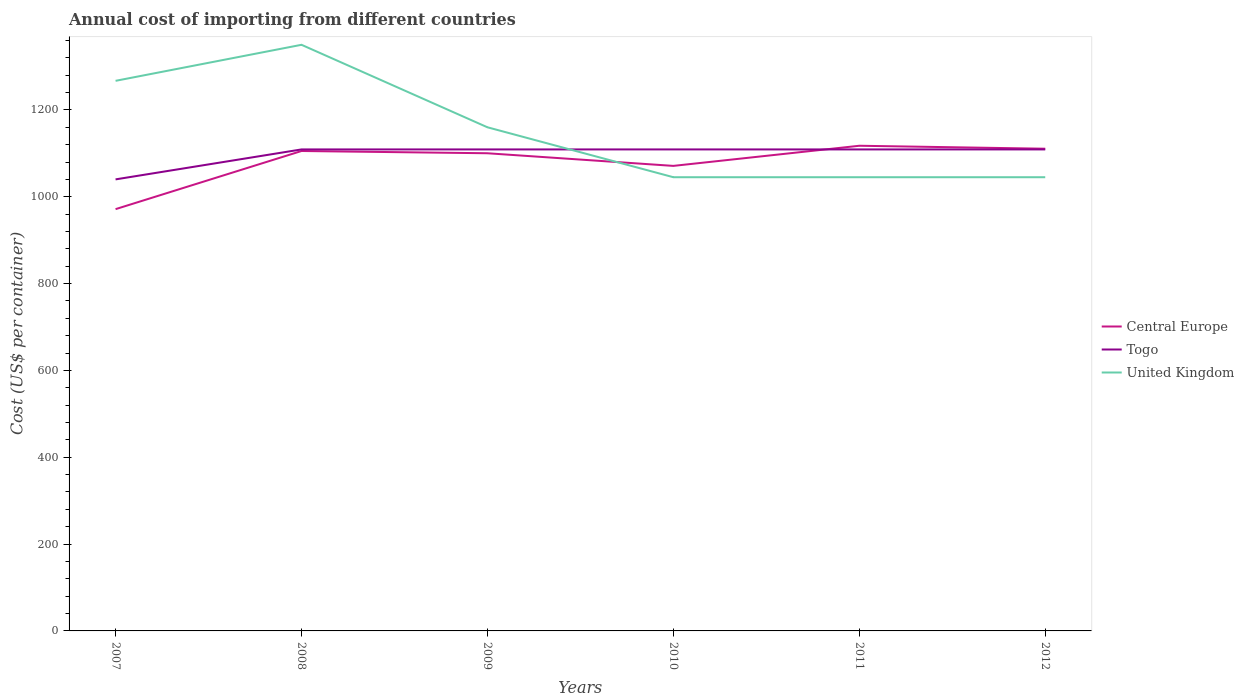How many different coloured lines are there?
Give a very brief answer. 3. Does the line corresponding to United Kingdom intersect with the line corresponding to Central Europe?
Provide a short and direct response. Yes. Across all years, what is the maximum total annual cost of importing in Central Europe?
Give a very brief answer. 971.45. What is the total total annual cost of importing in United Kingdom in the graph?
Your answer should be very brief. 107. What is the difference between the highest and the second highest total annual cost of importing in United Kingdom?
Provide a succinct answer. 305. Is the total annual cost of importing in United Kingdom strictly greater than the total annual cost of importing in Togo over the years?
Give a very brief answer. No. How many lines are there?
Your answer should be very brief. 3. How many legend labels are there?
Keep it short and to the point. 3. What is the title of the graph?
Offer a terse response. Annual cost of importing from different countries. What is the label or title of the Y-axis?
Your answer should be very brief. Cost (US$ per container). What is the Cost (US$ per container) of Central Europe in 2007?
Make the answer very short. 971.45. What is the Cost (US$ per container) in Togo in 2007?
Ensure brevity in your answer.  1040. What is the Cost (US$ per container) of United Kingdom in 2007?
Your answer should be very brief. 1267. What is the Cost (US$ per container) of Central Europe in 2008?
Ensure brevity in your answer.  1105.36. What is the Cost (US$ per container) of Togo in 2008?
Offer a very short reply. 1109. What is the Cost (US$ per container) of United Kingdom in 2008?
Offer a very short reply. 1350. What is the Cost (US$ per container) in Central Europe in 2009?
Your response must be concise. 1100.18. What is the Cost (US$ per container) in Togo in 2009?
Offer a terse response. 1109. What is the Cost (US$ per container) of United Kingdom in 2009?
Provide a succinct answer. 1160. What is the Cost (US$ per container) of Central Europe in 2010?
Your answer should be compact. 1071.09. What is the Cost (US$ per container) of Togo in 2010?
Your answer should be very brief. 1109. What is the Cost (US$ per container) in United Kingdom in 2010?
Give a very brief answer. 1045. What is the Cost (US$ per container) in Central Europe in 2011?
Your answer should be very brief. 1117.45. What is the Cost (US$ per container) in Togo in 2011?
Offer a very short reply. 1109. What is the Cost (US$ per container) of United Kingdom in 2011?
Your response must be concise. 1045. What is the Cost (US$ per container) of Central Europe in 2012?
Offer a terse response. 1110.64. What is the Cost (US$ per container) in Togo in 2012?
Keep it short and to the point. 1109. What is the Cost (US$ per container) in United Kingdom in 2012?
Provide a short and direct response. 1045. Across all years, what is the maximum Cost (US$ per container) of Central Europe?
Keep it short and to the point. 1117.45. Across all years, what is the maximum Cost (US$ per container) of Togo?
Offer a terse response. 1109. Across all years, what is the maximum Cost (US$ per container) in United Kingdom?
Give a very brief answer. 1350. Across all years, what is the minimum Cost (US$ per container) in Central Europe?
Offer a very short reply. 971.45. Across all years, what is the minimum Cost (US$ per container) in Togo?
Offer a very short reply. 1040. Across all years, what is the minimum Cost (US$ per container) in United Kingdom?
Offer a very short reply. 1045. What is the total Cost (US$ per container) of Central Europe in the graph?
Provide a short and direct response. 6476.18. What is the total Cost (US$ per container) of Togo in the graph?
Give a very brief answer. 6585. What is the total Cost (US$ per container) of United Kingdom in the graph?
Your answer should be very brief. 6912. What is the difference between the Cost (US$ per container) of Central Europe in 2007 and that in 2008?
Your response must be concise. -133.91. What is the difference between the Cost (US$ per container) of Togo in 2007 and that in 2008?
Keep it short and to the point. -69. What is the difference between the Cost (US$ per container) of United Kingdom in 2007 and that in 2008?
Provide a short and direct response. -83. What is the difference between the Cost (US$ per container) of Central Europe in 2007 and that in 2009?
Provide a short and direct response. -128.73. What is the difference between the Cost (US$ per container) of Togo in 2007 and that in 2009?
Your answer should be compact. -69. What is the difference between the Cost (US$ per container) in United Kingdom in 2007 and that in 2009?
Provide a succinct answer. 107. What is the difference between the Cost (US$ per container) of Central Europe in 2007 and that in 2010?
Give a very brief answer. -99.64. What is the difference between the Cost (US$ per container) in Togo in 2007 and that in 2010?
Ensure brevity in your answer.  -69. What is the difference between the Cost (US$ per container) in United Kingdom in 2007 and that in 2010?
Your answer should be very brief. 222. What is the difference between the Cost (US$ per container) in Central Europe in 2007 and that in 2011?
Ensure brevity in your answer.  -146. What is the difference between the Cost (US$ per container) in Togo in 2007 and that in 2011?
Make the answer very short. -69. What is the difference between the Cost (US$ per container) in United Kingdom in 2007 and that in 2011?
Ensure brevity in your answer.  222. What is the difference between the Cost (US$ per container) in Central Europe in 2007 and that in 2012?
Make the answer very short. -139.18. What is the difference between the Cost (US$ per container) in Togo in 2007 and that in 2012?
Offer a terse response. -69. What is the difference between the Cost (US$ per container) in United Kingdom in 2007 and that in 2012?
Your response must be concise. 222. What is the difference between the Cost (US$ per container) in Central Europe in 2008 and that in 2009?
Your answer should be very brief. 5.18. What is the difference between the Cost (US$ per container) in United Kingdom in 2008 and that in 2009?
Your response must be concise. 190. What is the difference between the Cost (US$ per container) of Central Europe in 2008 and that in 2010?
Offer a terse response. 34.27. What is the difference between the Cost (US$ per container) in Togo in 2008 and that in 2010?
Make the answer very short. 0. What is the difference between the Cost (US$ per container) in United Kingdom in 2008 and that in 2010?
Provide a short and direct response. 305. What is the difference between the Cost (US$ per container) in Central Europe in 2008 and that in 2011?
Ensure brevity in your answer.  -12.09. What is the difference between the Cost (US$ per container) of Togo in 2008 and that in 2011?
Your answer should be compact. 0. What is the difference between the Cost (US$ per container) in United Kingdom in 2008 and that in 2011?
Your response must be concise. 305. What is the difference between the Cost (US$ per container) in Central Europe in 2008 and that in 2012?
Ensure brevity in your answer.  -5.27. What is the difference between the Cost (US$ per container) in Togo in 2008 and that in 2012?
Offer a terse response. 0. What is the difference between the Cost (US$ per container) of United Kingdom in 2008 and that in 2012?
Give a very brief answer. 305. What is the difference between the Cost (US$ per container) in Central Europe in 2009 and that in 2010?
Give a very brief answer. 29.09. What is the difference between the Cost (US$ per container) of Togo in 2009 and that in 2010?
Provide a short and direct response. 0. What is the difference between the Cost (US$ per container) of United Kingdom in 2009 and that in 2010?
Your answer should be very brief. 115. What is the difference between the Cost (US$ per container) of Central Europe in 2009 and that in 2011?
Your answer should be very brief. -17.27. What is the difference between the Cost (US$ per container) of Togo in 2009 and that in 2011?
Provide a short and direct response. 0. What is the difference between the Cost (US$ per container) of United Kingdom in 2009 and that in 2011?
Your answer should be compact. 115. What is the difference between the Cost (US$ per container) in Central Europe in 2009 and that in 2012?
Provide a succinct answer. -10.45. What is the difference between the Cost (US$ per container) of United Kingdom in 2009 and that in 2012?
Your answer should be compact. 115. What is the difference between the Cost (US$ per container) of Central Europe in 2010 and that in 2011?
Offer a very short reply. -46.36. What is the difference between the Cost (US$ per container) of United Kingdom in 2010 and that in 2011?
Ensure brevity in your answer.  0. What is the difference between the Cost (US$ per container) of Central Europe in 2010 and that in 2012?
Your answer should be compact. -39.55. What is the difference between the Cost (US$ per container) of Togo in 2010 and that in 2012?
Offer a very short reply. 0. What is the difference between the Cost (US$ per container) of Central Europe in 2011 and that in 2012?
Ensure brevity in your answer.  6.82. What is the difference between the Cost (US$ per container) in United Kingdom in 2011 and that in 2012?
Your answer should be very brief. 0. What is the difference between the Cost (US$ per container) in Central Europe in 2007 and the Cost (US$ per container) in Togo in 2008?
Keep it short and to the point. -137.55. What is the difference between the Cost (US$ per container) of Central Europe in 2007 and the Cost (US$ per container) of United Kingdom in 2008?
Offer a very short reply. -378.55. What is the difference between the Cost (US$ per container) in Togo in 2007 and the Cost (US$ per container) in United Kingdom in 2008?
Keep it short and to the point. -310. What is the difference between the Cost (US$ per container) in Central Europe in 2007 and the Cost (US$ per container) in Togo in 2009?
Provide a short and direct response. -137.55. What is the difference between the Cost (US$ per container) of Central Europe in 2007 and the Cost (US$ per container) of United Kingdom in 2009?
Your response must be concise. -188.55. What is the difference between the Cost (US$ per container) of Togo in 2007 and the Cost (US$ per container) of United Kingdom in 2009?
Offer a terse response. -120. What is the difference between the Cost (US$ per container) in Central Europe in 2007 and the Cost (US$ per container) in Togo in 2010?
Provide a succinct answer. -137.55. What is the difference between the Cost (US$ per container) of Central Europe in 2007 and the Cost (US$ per container) of United Kingdom in 2010?
Make the answer very short. -73.55. What is the difference between the Cost (US$ per container) in Central Europe in 2007 and the Cost (US$ per container) in Togo in 2011?
Make the answer very short. -137.55. What is the difference between the Cost (US$ per container) in Central Europe in 2007 and the Cost (US$ per container) in United Kingdom in 2011?
Keep it short and to the point. -73.55. What is the difference between the Cost (US$ per container) in Central Europe in 2007 and the Cost (US$ per container) in Togo in 2012?
Offer a terse response. -137.55. What is the difference between the Cost (US$ per container) of Central Europe in 2007 and the Cost (US$ per container) of United Kingdom in 2012?
Provide a short and direct response. -73.55. What is the difference between the Cost (US$ per container) of Togo in 2007 and the Cost (US$ per container) of United Kingdom in 2012?
Offer a terse response. -5. What is the difference between the Cost (US$ per container) in Central Europe in 2008 and the Cost (US$ per container) in Togo in 2009?
Your answer should be compact. -3.64. What is the difference between the Cost (US$ per container) in Central Europe in 2008 and the Cost (US$ per container) in United Kingdom in 2009?
Provide a succinct answer. -54.64. What is the difference between the Cost (US$ per container) of Togo in 2008 and the Cost (US$ per container) of United Kingdom in 2009?
Offer a terse response. -51. What is the difference between the Cost (US$ per container) in Central Europe in 2008 and the Cost (US$ per container) in Togo in 2010?
Offer a terse response. -3.64. What is the difference between the Cost (US$ per container) in Central Europe in 2008 and the Cost (US$ per container) in United Kingdom in 2010?
Ensure brevity in your answer.  60.36. What is the difference between the Cost (US$ per container) in Togo in 2008 and the Cost (US$ per container) in United Kingdom in 2010?
Your answer should be compact. 64. What is the difference between the Cost (US$ per container) in Central Europe in 2008 and the Cost (US$ per container) in Togo in 2011?
Keep it short and to the point. -3.64. What is the difference between the Cost (US$ per container) in Central Europe in 2008 and the Cost (US$ per container) in United Kingdom in 2011?
Your answer should be very brief. 60.36. What is the difference between the Cost (US$ per container) of Central Europe in 2008 and the Cost (US$ per container) of Togo in 2012?
Your response must be concise. -3.64. What is the difference between the Cost (US$ per container) in Central Europe in 2008 and the Cost (US$ per container) in United Kingdom in 2012?
Make the answer very short. 60.36. What is the difference between the Cost (US$ per container) of Togo in 2008 and the Cost (US$ per container) of United Kingdom in 2012?
Your answer should be compact. 64. What is the difference between the Cost (US$ per container) of Central Europe in 2009 and the Cost (US$ per container) of Togo in 2010?
Your response must be concise. -8.82. What is the difference between the Cost (US$ per container) in Central Europe in 2009 and the Cost (US$ per container) in United Kingdom in 2010?
Offer a very short reply. 55.18. What is the difference between the Cost (US$ per container) of Central Europe in 2009 and the Cost (US$ per container) of Togo in 2011?
Make the answer very short. -8.82. What is the difference between the Cost (US$ per container) in Central Europe in 2009 and the Cost (US$ per container) in United Kingdom in 2011?
Offer a terse response. 55.18. What is the difference between the Cost (US$ per container) in Togo in 2009 and the Cost (US$ per container) in United Kingdom in 2011?
Your answer should be very brief. 64. What is the difference between the Cost (US$ per container) of Central Europe in 2009 and the Cost (US$ per container) of Togo in 2012?
Your answer should be very brief. -8.82. What is the difference between the Cost (US$ per container) of Central Europe in 2009 and the Cost (US$ per container) of United Kingdom in 2012?
Keep it short and to the point. 55.18. What is the difference between the Cost (US$ per container) in Central Europe in 2010 and the Cost (US$ per container) in Togo in 2011?
Keep it short and to the point. -37.91. What is the difference between the Cost (US$ per container) of Central Europe in 2010 and the Cost (US$ per container) of United Kingdom in 2011?
Offer a very short reply. 26.09. What is the difference between the Cost (US$ per container) in Togo in 2010 and the Cost (US$ per container) in United Kingdom in 2011?
Make the answer very short. 64. What is the difference between the Cost (US$ per container) of Central Europe in 2010 and the Cost (US$ per container) of Togo in 2012?
Provide a succinct answer. -37.91. What is the difference between the Cost (US$ per container) of Central Europe in 2010 and the Cost (US$ per container) of United Kingdom in 2012?
Ensure brevity in your answer.  26.09. What is the difference between the Cost (US$ per container) of Togo in 2010 and the Cost (US$ per container) of United Kingdom in 2012?
Give a very brief answer. 64. What is the difference between the Cost (US$ per container) in Central Europe in 2011 and the Cost (US$ per container) in Togo in 2012?
Offer a terse response. 8.45. What is the difference between the Cost (US$ per container) of Central Europe in 2011 and the Cost (US$ per container) of United Kingdom in 2012?
Provide a succinct answer. 72.45. What is the average Cost (US$ per container) in Central Europe per year?
Your response must be concise. 1079.36. What is the average Cost (US$ per container) in Togo per year?
Offer a terse response. 1097.5. What is the average Cost (US$ per container) in United Kingdom per year?
Your response must be concise. 1152. In the year 2007, what is the difference between the Cost (US$ per container) of Central Europe and Cost (US$ per container) of Togo?
Offer a very short reply. -68.55. In the year 2007, what is the difference between the Cost (US$ per container) in Central Europe and Cost (US$ per container) in United Kingdom?
Offer a terse response. -295.55. In the year 2007, what is the difference between the Cost (US$ per container) of Togo and Cost (US$ per container) of United Kingdom?
Give a very brief answer. -227. In the year 2008, what is the difference between the Cost (US$ per container) of Central Europe and Cost (US$ per container) of Togo?
Your response must be concise. -3.64. In the year 2008, what is the difference between the Cost (US$ per container) of Central Europe and Cost (US$ per container) of United Kingdom?
Your answer should be compact. -244.64. In the year 2008, what is the difference between the Cost (US$ per container) of Togo and Cost (US$ per container) of United Kingdom?
Keep it short and to the point. -241. In the year 2009, what is the difference between the Cost (US$ per container) of Central Europe and Cost (US$ per container) of Togo?
Make the answer very short. -8.82. In the year 2009, what is the difference between the Cost (US$ per container) in Central Europe and Cost (US$ per container) in United Kingdom?
Provide a succinct answer. -59.82. In the year 2009, what is the difference between the Cost (US$ per container) of Togo and Cost (US$ per container) of United Kingdom?
Give a very brief answer. -51. In the year 2010, what is the difference between the Cost (US$ per container) of Central Europe and Cost (US$ per container) of Togo?
Offer a very short reply. -37.91. In the year 2010, what is the difference between the Cost (US$ per container) of Central Europe and Cost (US$ per container) of United Kingdom?
Your response must be concise. 26.09. In the year 2010, what is the difference between the Cost (US$ per container) of Togo and Cost (US$ per container) of United Kingdom?
Your answer should be very brief. 64. In the year 2011, what is the difference between the Cost (US$ per container) of Central Europe and Cost (US$ per container) of Togo?
Offer a very short reply. 8.45. In the year 2011, what is the difference between the Cost (US$ per container) of Central Europe and Cost (US$ per container) of United Kingdom?
Give a very brief answer. 72.45. In the year 2012, what is the difference between the Cost (US$ per container) of Central Europe and Cost (US$ per container) of Togo?
Make the answer very short. 1.64. In the year 2012, what is the difference between the Cost (US$ per container) of Central Europe and Cost (US$ per container) of United Kingdom?
Give a very brief answer. 65.64. In the year 2012, what is the difference between the Cost (US$ per container) of Togo and Cost (US$ per container) of United Kingdom?
Your answer should be compact. 64. What is the ratio of the Cost (US$ per container) in Central Europe in 2007 to that in 2008?
Give a very brief answer. 0.88. What is the ratio of the Cost (US$ per container) in Togo in 2007 to that in 2008?
Give a very brief answer. 0.94. What is the ratio of the Cost (US$ per container) in United Kingdom in 2007 to that in 2008?
Your answer should be compact. 0.94. What is the ratio of the Cost (US$ per container) of Central Europe in 2007 to that in 2009?
Provide a short and direct response. 0.88. What is the ratio of the Cost (US$ per container) of Togo in 2007 to that in 2009?
Provide a short and direct response. 0.94. What is the ratio of the Cost (US$ per container) in United Kingdom in 2007 to that in 2009?
Your answer should be compact. 1.09. What is the ratio of the Cost (US$ per container) in Central Europe in 2007 to that in 2010?
Offer a terse response. 0.91. What is the ratio of the Cost (US$ per container) in Togo in 2007 to that in 2010?
Your answer should be very brief. 0.94. What is the ratio of the Cost (US$ per container) of United Kingdom in 2007 to that in 2010?
Provide a short and direct response. 1.21. What is the ratio of the Cost (US$ per container) of Central Europe in 2007 to that in 2011?
Offer a very short reply. 0.87. What is the ratio of the Cost (US$ per container) in Togo in 2007 to that in 2011?
Your response must be concise. 0.94. What is the ratio of the Cost (US$ per container) of United Kingdom in 2007 to that in 2011?
Provide a short and direct response. 1.21. What is the ratio of the Cost (US$ per container) of Central Europe in 2007 to that in 2012?
Provide a short and direct response. 0.87. What is the ratio of the Cost (US$ per container) of Togo in 2007 to that in 2012?
Make the answer very short. 0.94. What is the ratio of the Cost (US$ per container) of United Kingdom in 2007 to that in 2012?
Give a very brief answer. 1.21. What is the ratio of the Cost (US$ per container) in Central Europe in 2008 to that in 2009?
Give a very brief answer. 1. What is the ratio of the Cost (US$ per container) in United Kingdom in 2008 to that in 2009?
Provide a succinct answer. 1.16. What is the ratio of the Cost (US$ per container) in Central Europe in 2008 to that in 2010?
Provide a succinct answer. 1.03. What is the ratio of the Cost (US$ per container) in Togo in 2008 to that in 2010?
Ensure brevity in your answer.  1. What is the ratio of the Cost (US$ per container) in United Kingdom in 2008 to that in 2010?
Ensure brevity in your answer.  1.29. What is the ratio of the Cost (US$ per container) in United Kingdom in 2008 to that in 2011?
Keep it short and to the point. 1.29. What is the ratio of the Cost (US$ per container) in Central Europe in 2008 to that in 2012?
Keep it short and to the point. 1. What is the ratio of the Cost (US$ per container) in Togo in 2008 to that in 2012?
Your answer should be compact. 1. What is the ratio of the Cost (US$ per container) in United Kingdom in 2008 to that in 2012?
Your answer should be compact. 1.29. What is the ratio of the Cost (US$ per container) in Central Europe in 2009 to that in 2010?
Ensure brevity in your answer.  1.03. What is the ratio of the Cost (US$ per container) of United Kingdom in 2009 to that in 2010?
Provide a short and direct response. 1.11. What is the ratio of the Cost (US$ per container) in Central Europe in 2009 to that in 2011?
Ensure brevity in your answer.  0.98. What is the ratio of the Cost (US$ per container) of Togo in 2009 to that in 2011?
Offer a terse response. 1. What is the ratio of the Cost (US$ per container) in United Kingdom in 2009 to that in 2011?
Provide a succinct answer. 1.11. What is the ratio of the Cost (US$ per container) in Central Europe in 2009 to that in 2012?
Keep it short and to the point. 0.99. What is the ratio of the Cost (US$ per container) of Togo in 2009 to that in 2012?
Provide a succinct answer. 1. What is the ratio of the Cost (US$ per container) of United Kingdom in 2009 to that in 2012?
Make the answer very short. 1.11. What is the ratio of the Cost (US$ per container) in Central Europe in 2010 to that in 2011?
Provide a short and direct response. 0.96. What is the ratio of the Cost (US$ per container) of Togo in 2010 to that in 2011?
Make the answer very short. 1. What is the ratio of the Cost (US$ per container) in Central Europe in 2010 to that in 2012?
Give a very brief answer. 0.96. What is the ratio of the Cost (US$ per container) of United Kingdom in 2011 to that in 2012?
Your answer should be very brief. 1. What is the difference between the highest and the second highest Cost (US$ per container) of Central Europe?
Your response must be concise. 6.82. What is the difference between the highest and the lowest Cost (US$ per container) of Central Europe?
Your response must be concise. 146. What is the difference between the highest and the lowest Cost (US$ per container) of Togo?
Your response must be concise. 69. What is the difference between the highest and the lowest Cost (US$ per container) of United Kingdom?
Offer a terse response. 305. 